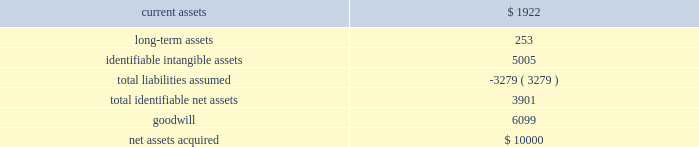58 2016 annual report note 12 .
Business acquisition bayside business solutions , inc .
Effective july 1 , 2015 , the company acquired all of the equity interests of bayside business solutions , an alabama-based company that provides technology solutions and payment processing services primarily for the financial services industry , for $ 10000 paid in cash .
This acquisition was funded using existing operating cash .
The acquisition of bayside business solutions expanded the company 2019s presence in commercial lending within the industry .
Management has completed a purchase price allocation of bayside business solutions and its assessment of the fair value of acquired assets and liabilities assumed .
The recognized amounts of identifiable assets acquired and liabilities assumed , based upon their fair values as of july 1 , 2015 are set forth below: .
The goodwill of $ 6099 arising from this acquisition consists largely of the growth potential , synergies and economies of scale expected from combining the operations of the company with those of bayside business solutions , together with the value of bayside business solutions 2019 assembled workforce .
Goodwill from this acquisition has been allocated to our banking systems and services segment .
The goodwill is not expected to be deductible for income tax purposes .
Identifiable intangible assets from this acquisition consist of customer relationships of $ 3402 , $ 659 of computer software and other intangible assets of $ 944 .
The weighted average amortization period for acquired customer relationships , acquired computer software , and other intangible assets is 15 years , 5 years , and 20 years , respectively .
Current assets were inclusive of cash acquired of $ 1725 .
The fair value of current assets acquired included accounts receivable of $ 178 .
The gross amount of receivables was $ 178 , none of which was expected to be uncollectible .
During fiscal year 2016 , the company incurred $ 55 in costs related to the acquisition of bayside business solutions .
These costs included fees for legal , valuation and other fees .
These costs were included within general and administrative expenses .
The results of bayside business solutions 2019 operations included in the company 2019s consolidated statement of income for the twelve months ended june 30 , 2016 included revenue of $ 4273 and after-tax net income of $ 303 .
The accompanying consolidated statements of income for the fiscal year ended june 30 , 2016 do not include any revenues and expenses related to this acquisition prior to the acquisition date .
The impact of this acquisition was considered immaterial to both the current and prior periods of our consolidated financial statements and pro forma financial information has not been provided .
Banno , llc effective march 1 , 2014 , the company acquired all of the equity interests of banno , an iowa-based company that provides web and transaction marketing services with a focus on the mobile medium , for $ 27910 paid in cash .
This acquisition was funded using existing operating cash .
The acquisition of banno expanded the company 2019s presence in online and mobile technologies within the industry .
During fiscal year 2014 , the company incurred $ 30 in costs related to the acquisition of banno .
These costs included fees for legal , valuation and other fees .
These costs were included within general and administrative expenses .
The results of banno's operations included in the company's consolidated statements of income for the year ended june 30 , 2016 included revenue of $ 6393 and after-tax net loss of $ 1289 .
For the year ended june 30 , 2015 , our consolidated statements of income included revenue of $ 4175 and after-tax net loss of $ 1784 attributable to banno .
The results of banno 2019s operations included in the company 2019s consolidated statement of operations from the acquisition date to june 30 , 2014 included revenue of $ 848 and after-tax net loss of $ 1121 .
The accompanying consolidated statements of income for the twelve month period ended june 30 , 2016 do not include any revenues and expenses related to this acquisition prior to the acquisition date .
The impact of this acquisition was considered immaterial to both the current and prior periods of our consolidated financial statements and pro forma financial information has not been provided. .
What percentage of the company's net assets are considered long-term assets? 
Rationale: long term assets divided by net assets
Computations: (253 / 10000)
Answer: 0.0253. 